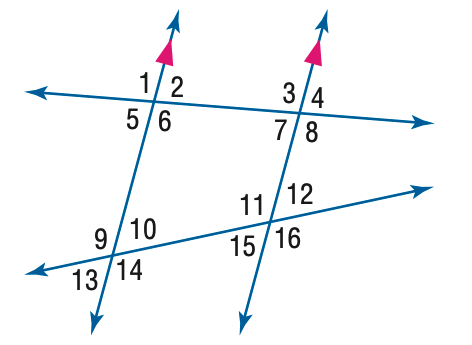Answer the mathemtical geometry problem and directly provide the correct option letter.
Question: In the figure, m \angle 3 = 110 and m \angle 12 = 55. Find the measure of \angle 15.
Choices: A: 50 B: 55 C: 65 D: 70 B 